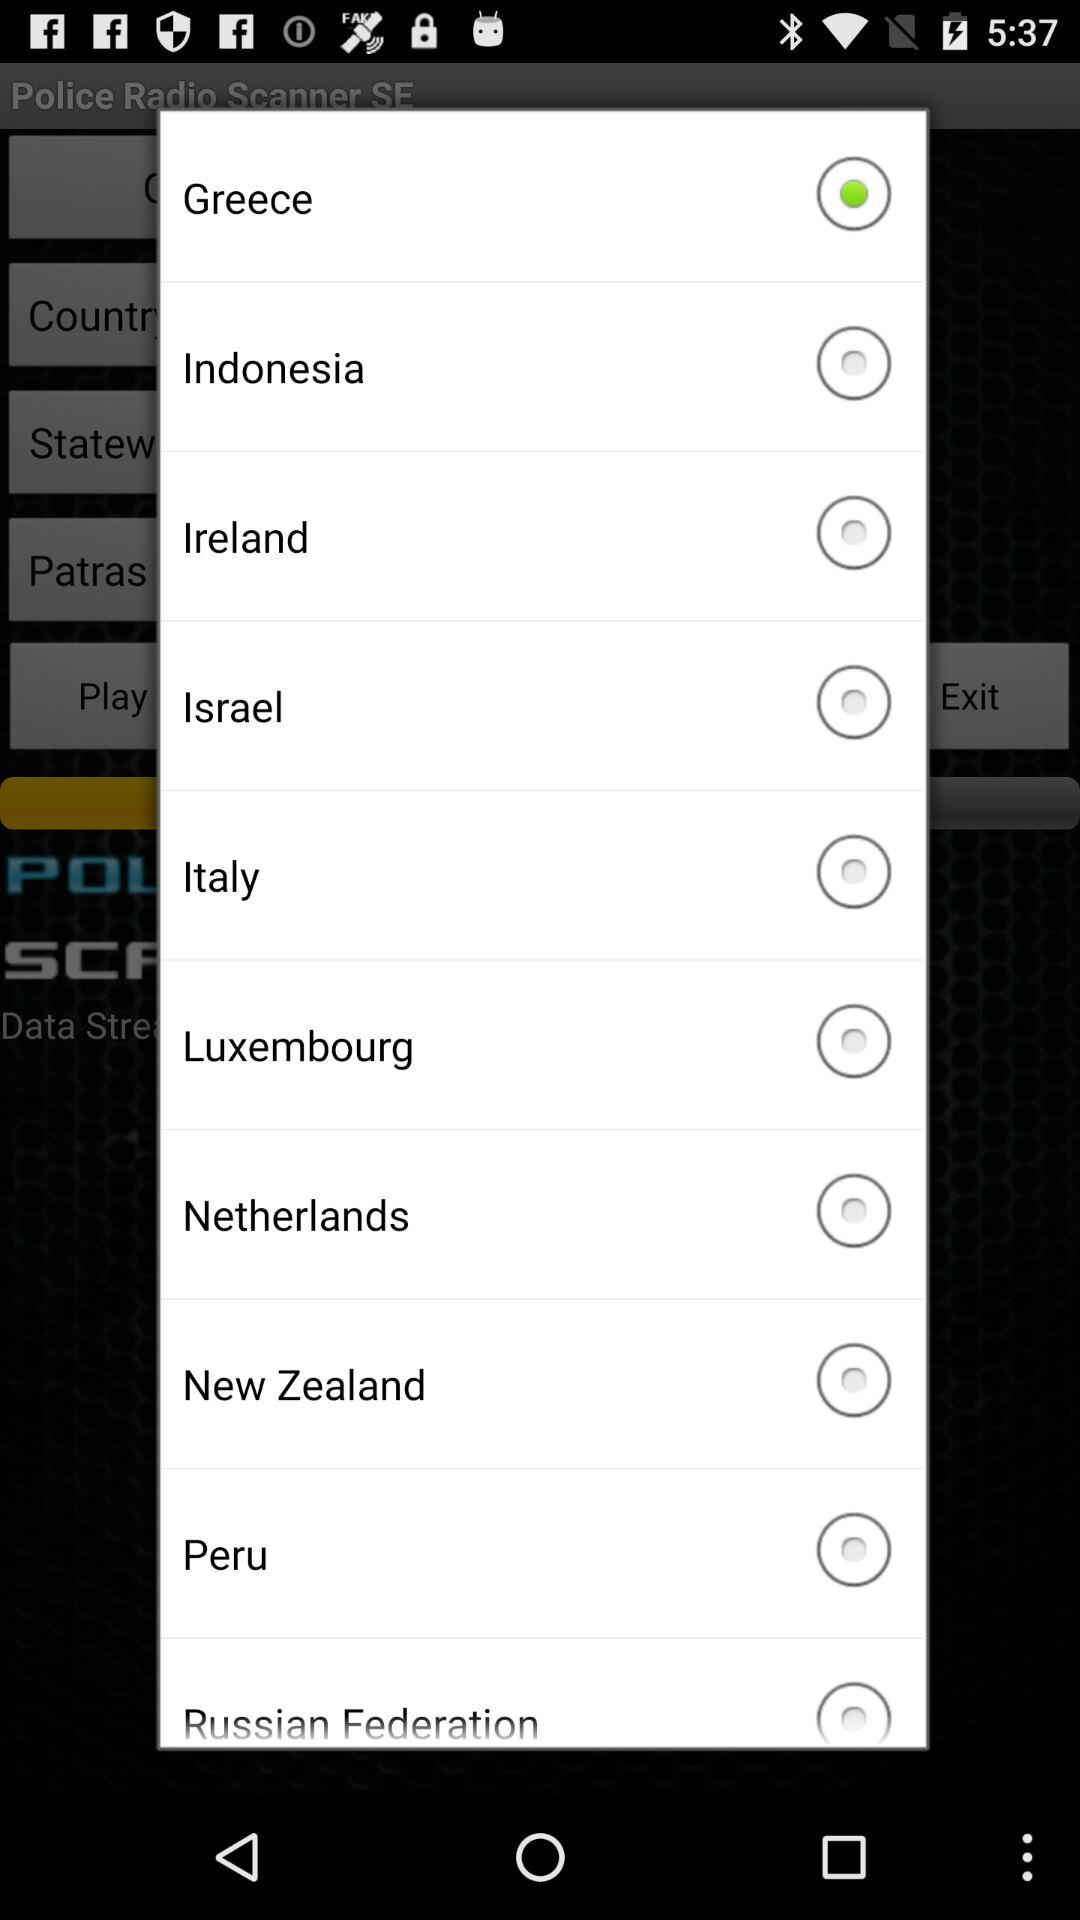Which country is selected? The selected country is Greece. 